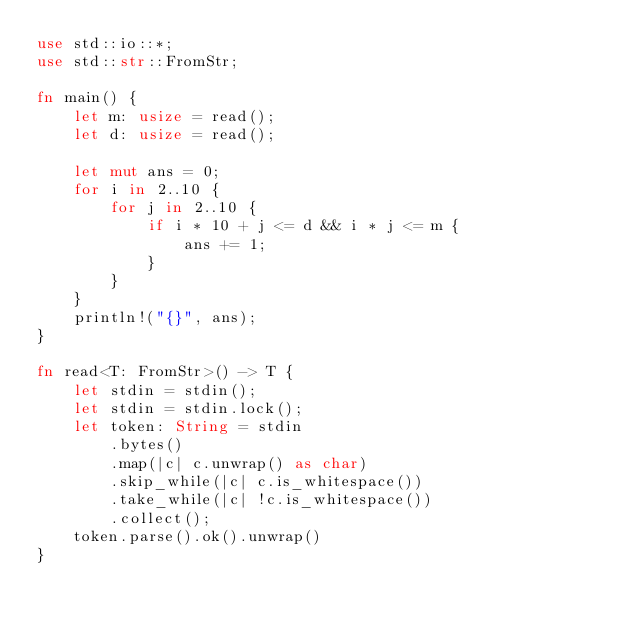<code> <loc_0><loc_0><loc_500><loc_500><_Rust_>use std::io::*;
use std::str::FromStr;

fn main() {
    let m: usize = read();
    let d: usize = read();
    
    let mut ans = 0;
    for i in 2..10 {
        for j in 2..10 {
            if i * 10 + j <= d && i * j <= m {
                ans += 1;
            }
        }
    }
    println!("{}", ans);
}

fn read<T: FromStr>() -> T {
    let stdin = stdin();
    let stdin = stdin.lock();
    let token: String = stdin
        .bytes()
        .map(|c| c.unwrap() as char)
        .skip_while(|c| c.is_whitespace())
        .take_while(|c| !c.is_whitespace())
        .collect();
    token.parse().ok().unwrap()
}
</code> 